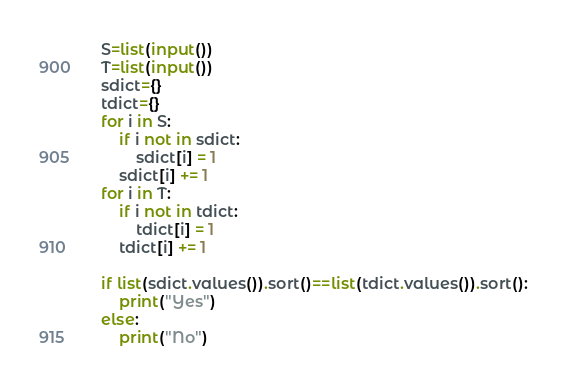Convert code to text. <code><loc_0><loc_0><loc_500><loc_500><_Python_>S=list(input())
T=list(input())
sdict={}
tdict={}
for i in S:
    if i not in sdict:
        sdict[i] = 1
    sdict[i] += 1
for i in T:
    if i not in tdict:
        tdict[i] = 1
    tdict[i] += 1
    
if list(sdict.values()).sort()==list(tdict.values()).sort():
    print("Yes")
else:
    print("No")</code> 